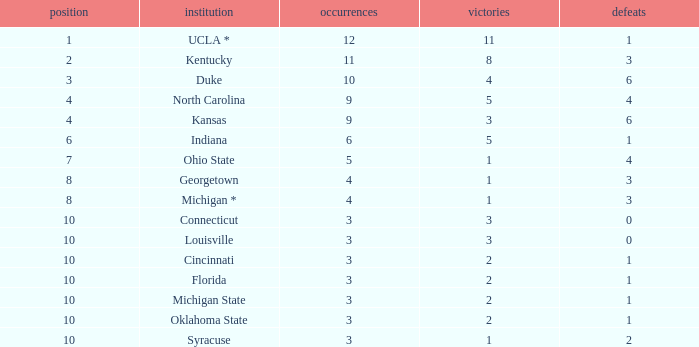Tell me the sum of losses for wins less than 2 and rank of 10 with appearances larger than 3 None. 